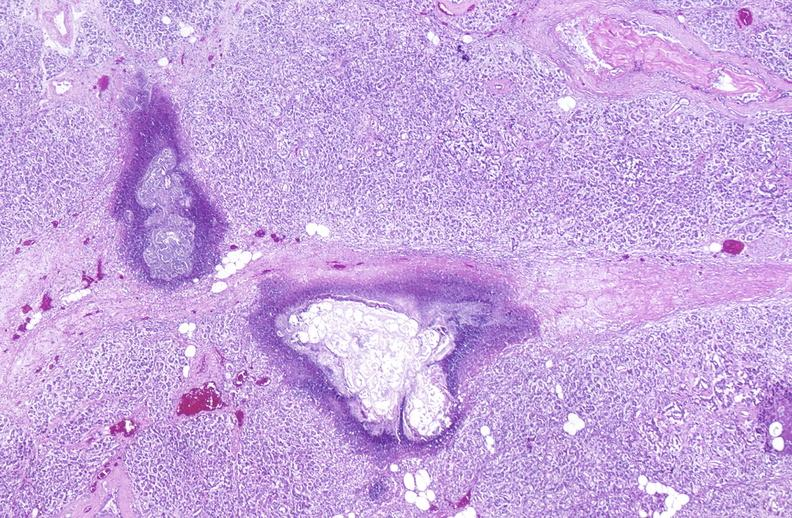where is this?
Answer the question using a single word or phrase. Pancreas 